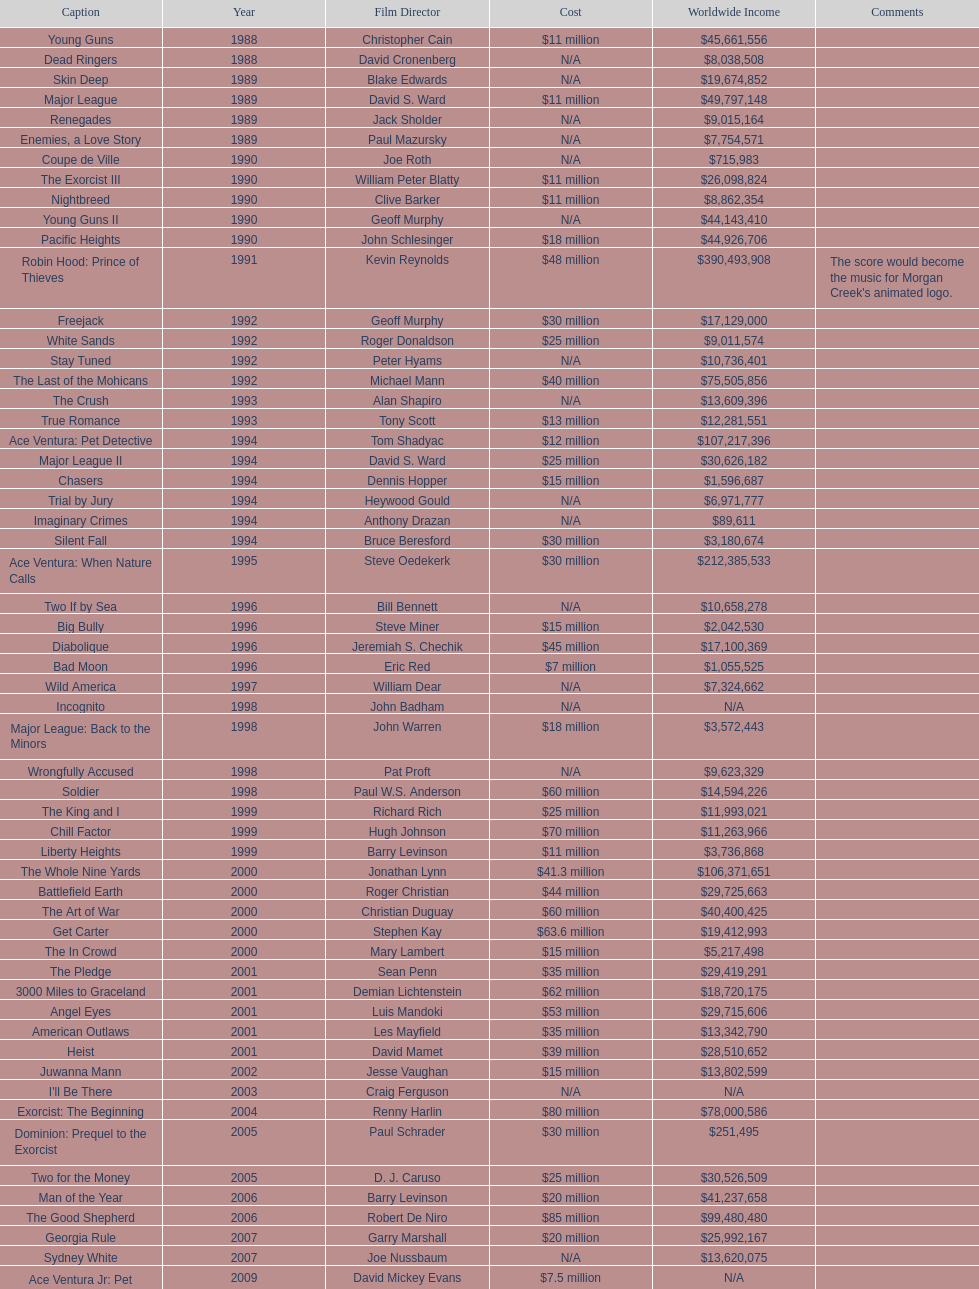What movie was made immediately before the pledge? The In Crowd. 